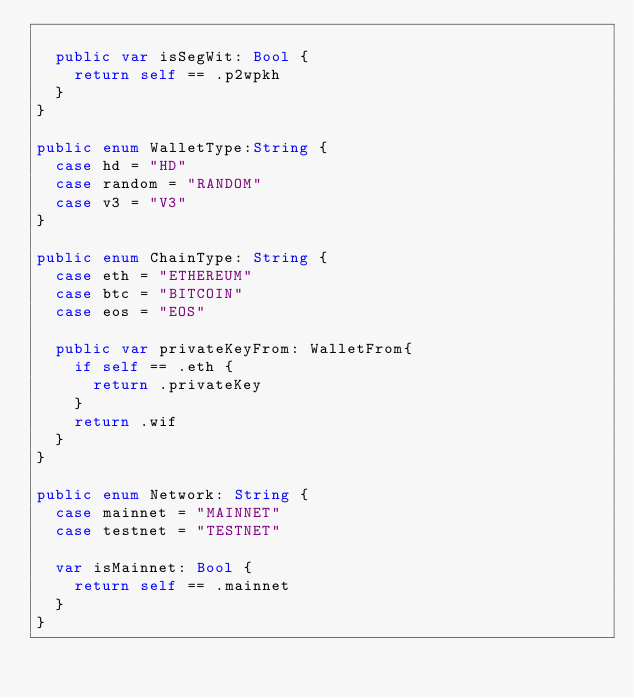<code> <loc_0><loc_0><loc_500><loc_500><_Swift_>  
  public var isSegWit: Bool {
    return self == .p2wpkh
  }
}

public enum WalletType:String {
  case hd = "HD"
  case random = "RANDOM"
  case v3 = "V3"
}

public enum ChainType: String {
  case eth = "ETHEREUM"
  case btc = "BITCOIN"
  case eos = "EOS"
  
  public var privateKeyFrom: WalletFrom{
    if self == .eth {
      return .privateKey
    }
    return .wif
  }
}

public enum Network: String {
  case mainnet = "MAINNET"
  case testnet = "TESTNET"
  
  var isMainnet: Bool {
    return self == .mainnet
  }
}


</code> 